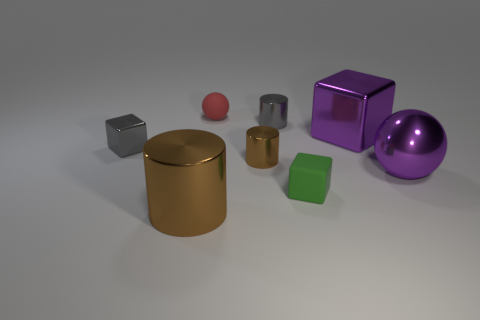Does the big cylinder have the same color as the large shiny sphere?
Provide a short and direct response. No. There is a small metallic object that is both on the right side of the gray block and on the left side of the small gray cylinder; what is its color?
Make the answer very short. Brown. Are there any red matte balls right of the small gray cylinder?
Offer a very short reply. No. There is a cube that is on the right side of the small matte block; how many objects are on the right side of it?
Ensure brevity in your answer.  1. There is a thing that is the same material as the small red sphere; what is its size?
Make the answer very short. Small. The metal ball is what size?
Make the answer very short. Large. Are the tiny gray block and the green cube made of the same material?
Your response must be concise. No. How many cubes are either small gray shiny objects or green things?
Ensure brevity in your answer.  2. There is a matte thing in front of the purple thing that is in front of the big purple metallic cube; what color is it?
Provide a short and direct response. Green. There is a metal object that is the same color as the large metal sphere; what is its size?
Offer a terse response. Large. 